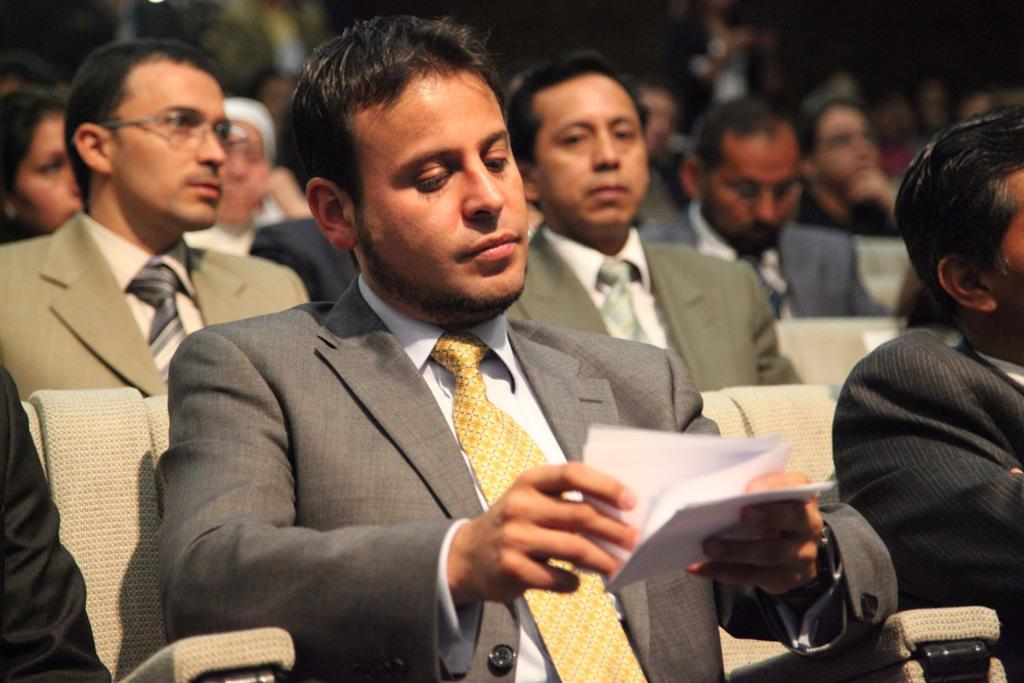What is the man in the image doing? The man is sitting on a chair in the image. What is the man holding in the image? The man is holding a paper. How many people are sitting on chairs in the image? There is a group of people sitting on chairs in the image. Can you describe the background of the image? The background of the image is blurred. How many chairs are being dropped in the image? There are no chairs being dropped in the image; the people are sitting on chairs. What type of measuring device is being used in the image? There is no measuring device present in the image. 